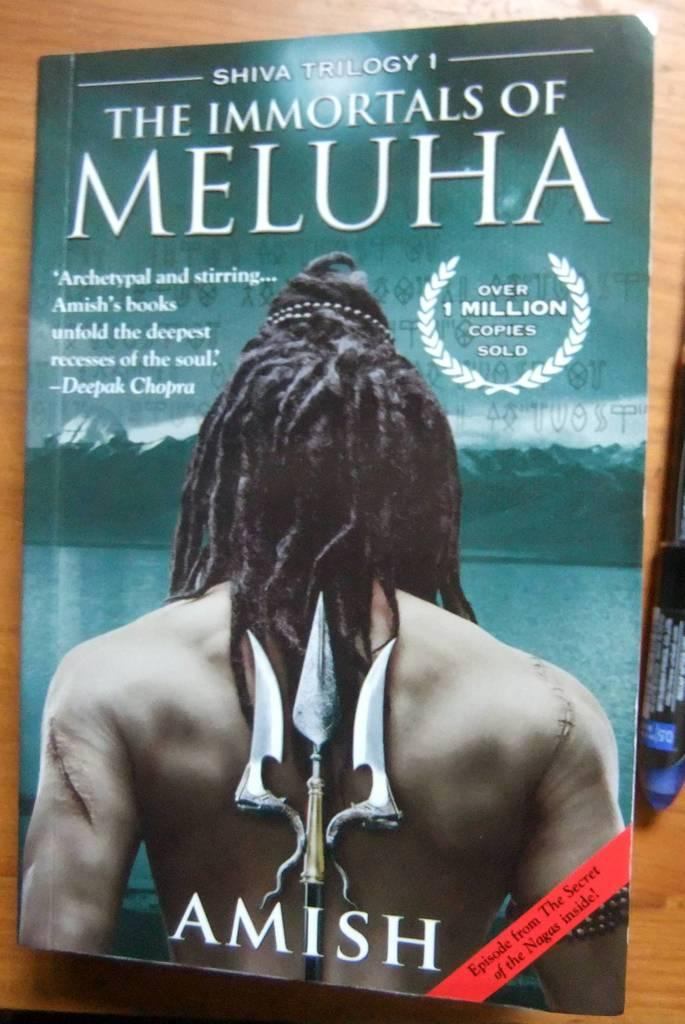What can be seen in the image related to reading or writing? There is a book and a pen on a wooden surface in the image. What is the book's appearance? The book has text on it and an image of a person. What is the wooden surface in the image? The wooden surface is not described in the facts, so we cannot definitively answer this question. Can you describe the object in the image? The facts only mention that there is an object in the image, but its appearance or function is not specified. How does the girl feel about the thrill of the woman in the image? There is no girl or woman present in the image, so we cannot answer this question. 